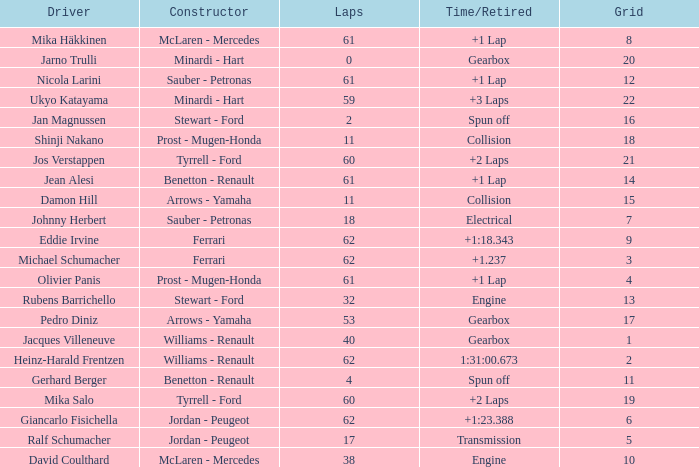What is the average number of laps that has a Time/Retired of +1 lap, a Driver of olivier panis, and a Grid larger than 4? None. 